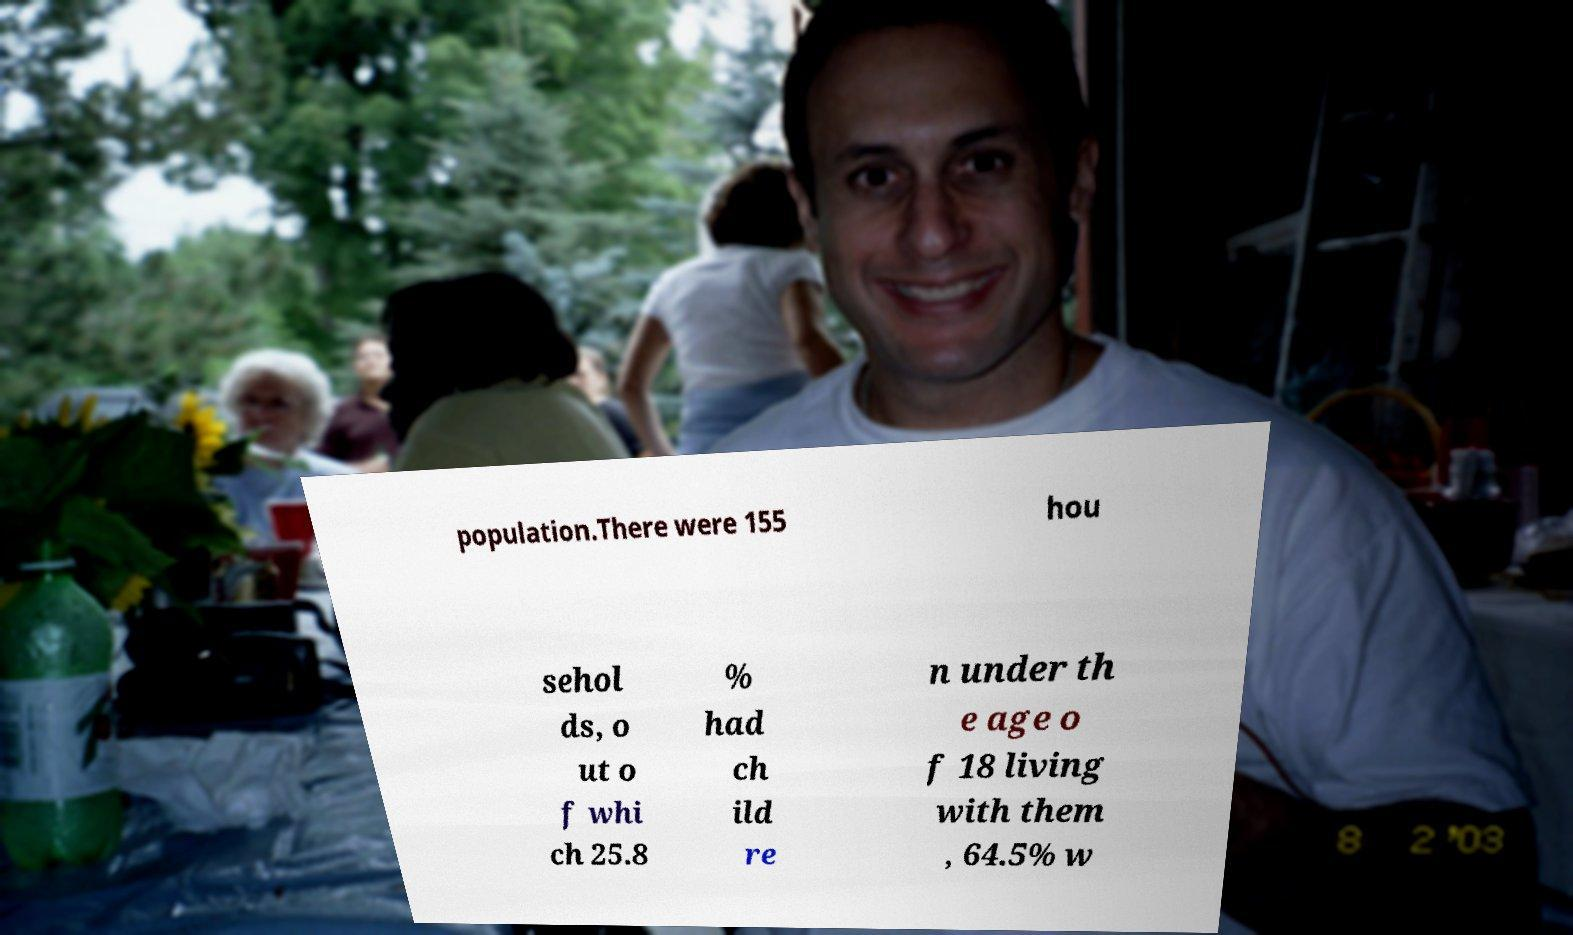I need the written content from this picture converted into text. Can you do that? population.There were 155 hou sehol ds, o ut o f whi ch 25.8 % had ch ild re n under th e age o f 18 living with them , 64.5% w 